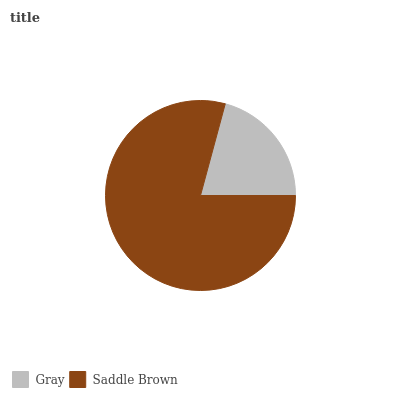Is Gray the minimum?
Answer yes or no. Yes. Is Saddle Brown the maximum?
Answer yes or no. Yes. Is Saddle Brown the minimum?
Answer yes or no. No. Is Saddle Brown greater than Gray?
Answer yes or no. Yes. Is Gray less than Saddle Brown?
Answer yes or no. Yes. Is Gray greater than Saddle Brown?
Answer yes or no. No. Is Saddle Brown less than Gray?
Answer yes or no. No. Is Saddle Brown the high median?
Answer yes or no. Yes. Is Gray the low median?
Answer yes or no. Yes. Is Gray the high median?
Answer yes or no. No. Is Saddle Brown the low median?
Answer yes or no. No. 